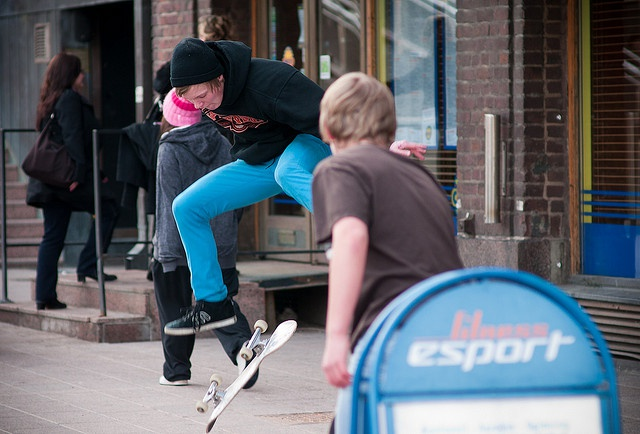Describe the objects in this image and their specific colors. I can see people in black and gray tones, people in black, teal, and gray tones, people in black, gray, maroon, and darkgray tones, people in black, gray, and darkblue tones, and skateboard in black, lightgray, and darkgray tones in this image. 